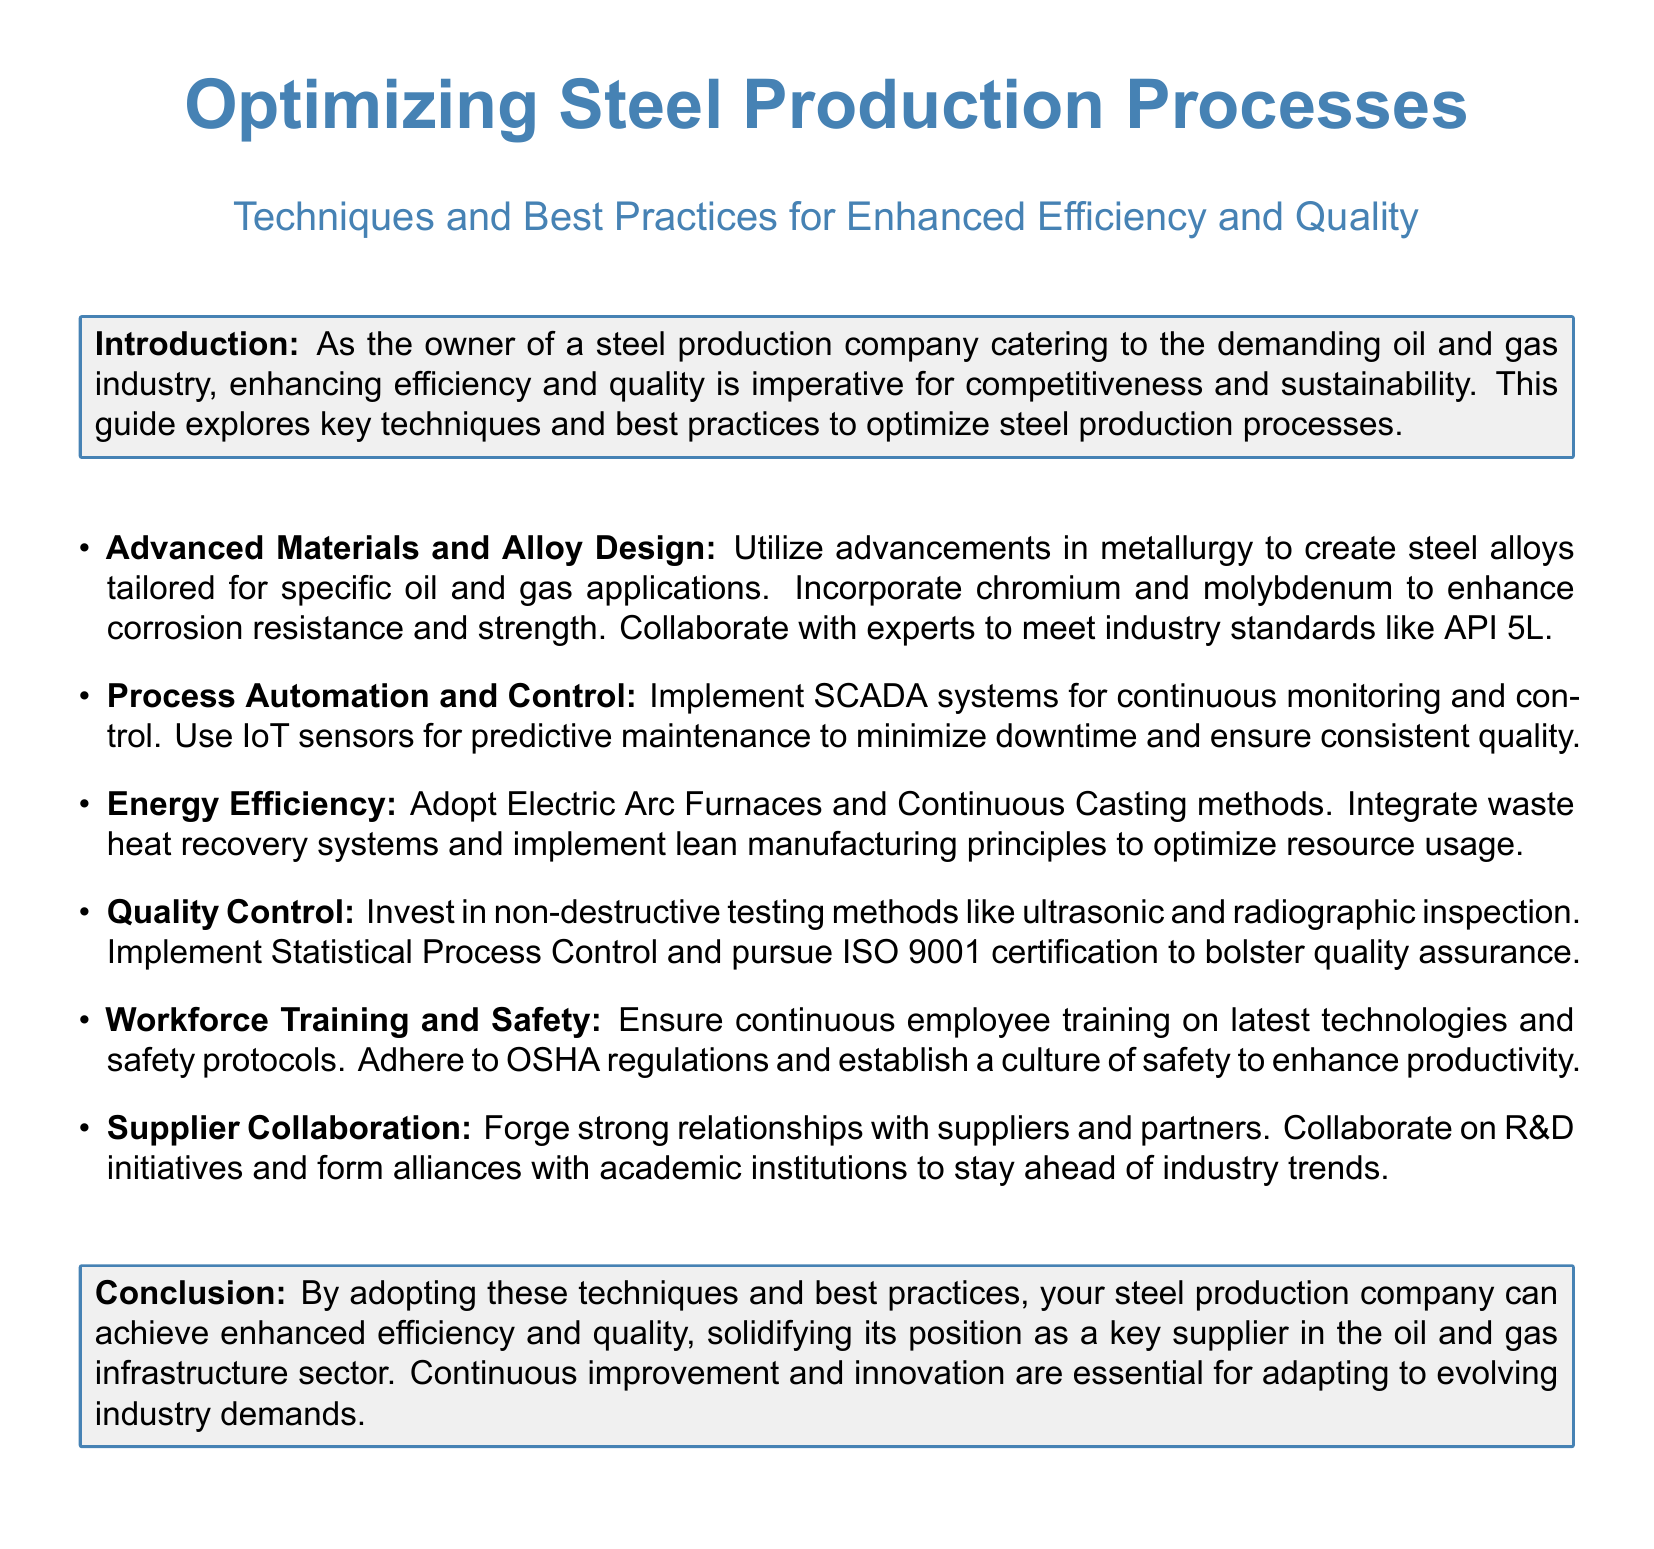What is the main focus of the guide? The main focus of the guide is on optimizing steel production processes for enhanced efficiency and quality.
Answer: optimizing steel production processes What industry does the steel production company cater to? The document states that it caters to the oil and gas industry.
Answer: oil and gas industry Which advanced materials are suggested for enhancing corrosion resistance? The guide suggests incorporating chromium and molybdenum for enhancing corrosion resistance.
Answer: chromium and molybdenum What certification is recommended for quality assurance? The document recommends pursuing ISO 9001 certification for quality assurance.
Answer: ISO 9001 What system is suggested for continuous monitoring and control? The guide suggests implementing SCADA systems for continuous monitoring and control.
Answer: SCADA systems What principle is recommended to optimize resource usage? The document mentions implementing lean manufacturing principles to optimize resource usage.
Answer: lean manufacturing principles What is emphasized as essential for adapting to industry demands? The conclusion emphasizes that continuous improvement and innovation are essential for adapting to evolving industry demands.
Answer: continuous improvement and innovation What type of training should be provided to employees? The document states that continuous employee training on latest technologies and safety protocols should be provided.
Answer: latest technologies and safety protocols 